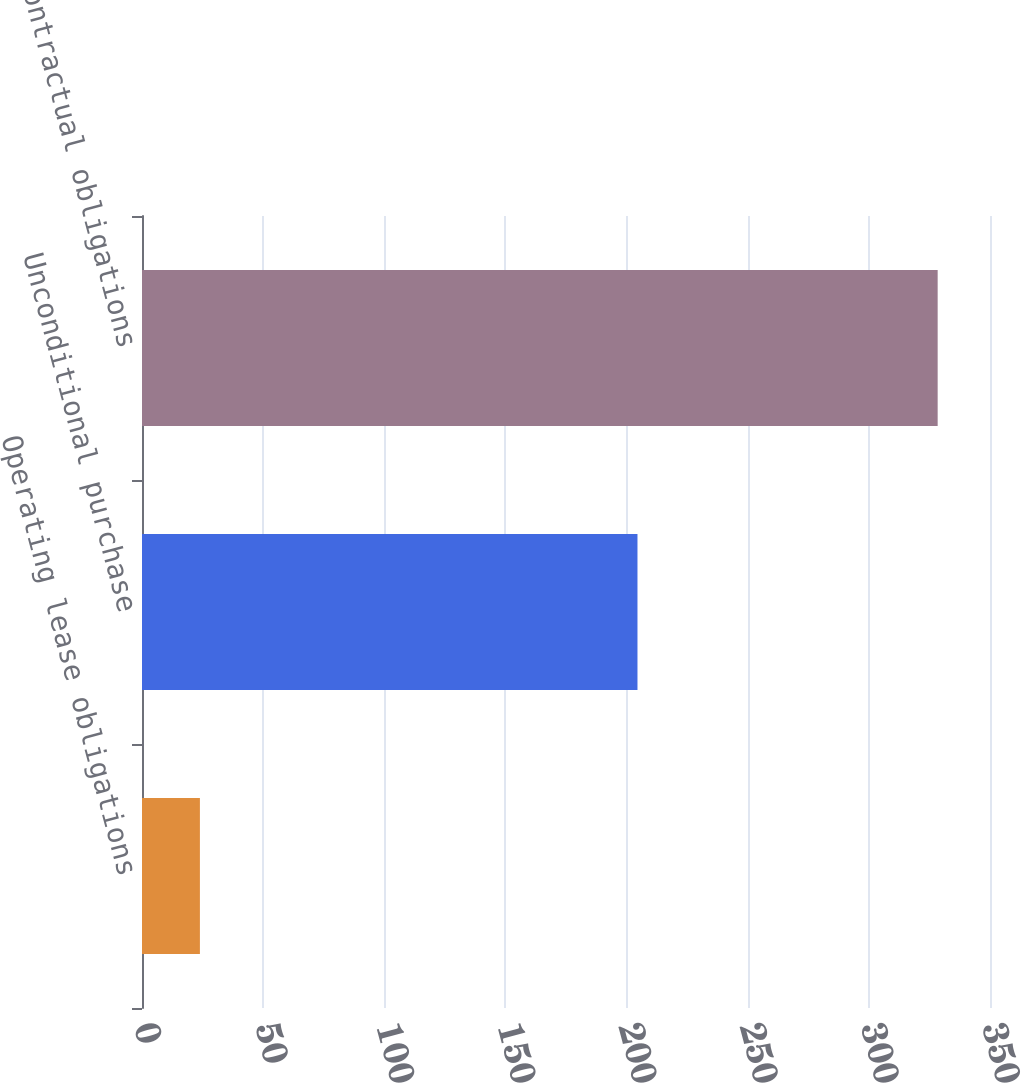<chart> <loc_0><loc_0><loc_500><loc_500><bar_chart><fcel>Operating lease obligations<fcel>Unconditional purchase<fcel>Total contractual obligations<nl><fcel>23.9<fcel>204.5<fcel>328.4<nl></chart> 